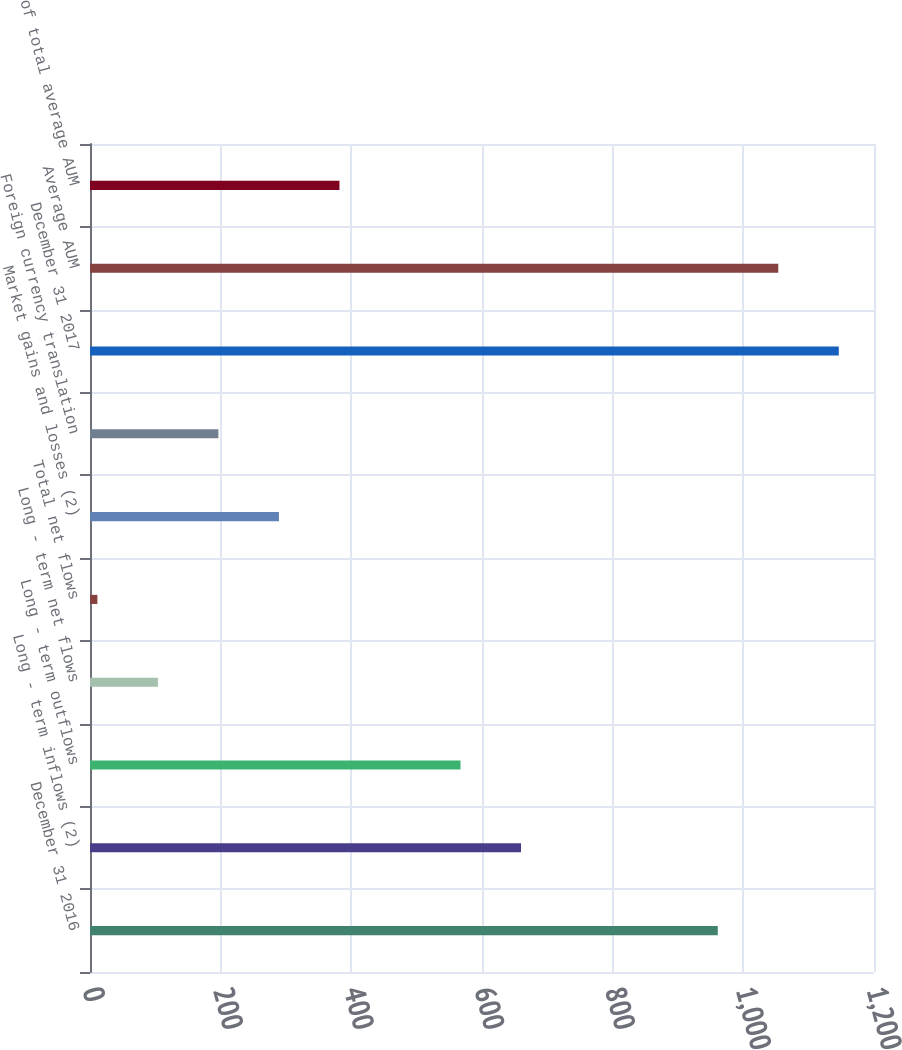Convert chart. <chart><loc_0><loc_0><loc_500><loc_500><bar_chart><fcel>December 31 2016<fcel>Long - term inflows (2)<fcel>Long - term outflows<fcel>Long - term net flows<fcel>Total net flows<fcel>Market gains and losses (2)<fcel>Foreign currency translation<fcel>December 31 2017<fcel>Average AUM<fcel>of total average AUM<nl><fcel>960.86<fcel>659.71<fcel>567.08<fcel>103.93<fcel>11.3<fcel>289.19<fcel>196.56<fcel>1146.12<fcel>1053.49<fcel>381.82<nl></chart> 